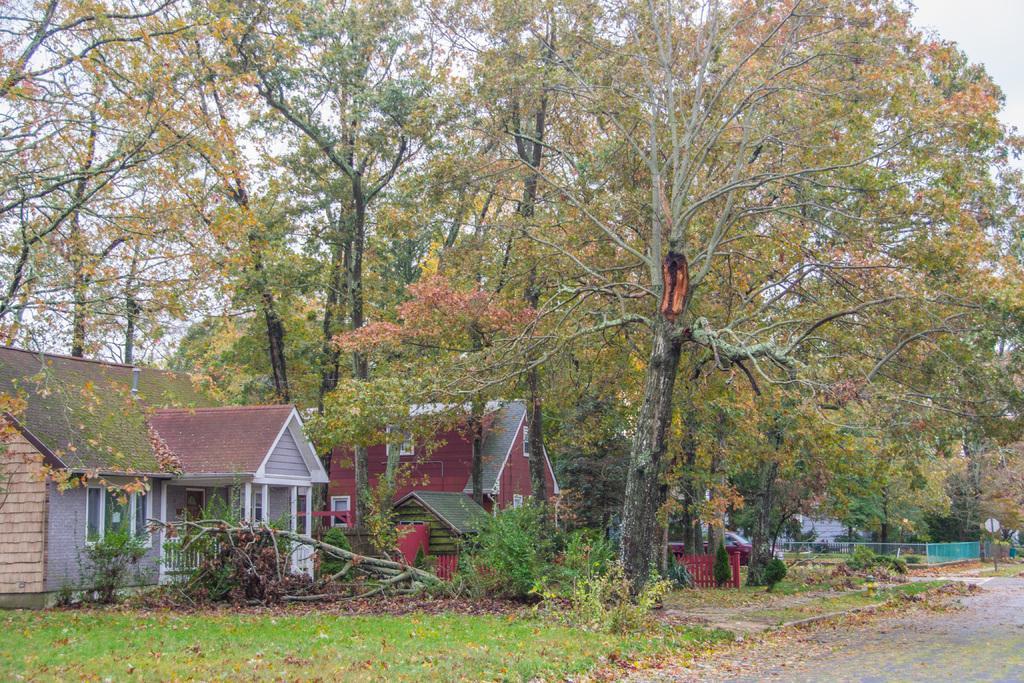Could you give a brief overview of what you see in this image? In this picture I can see there are some buildings, trees, plants and there is a road and the sky is clear. 